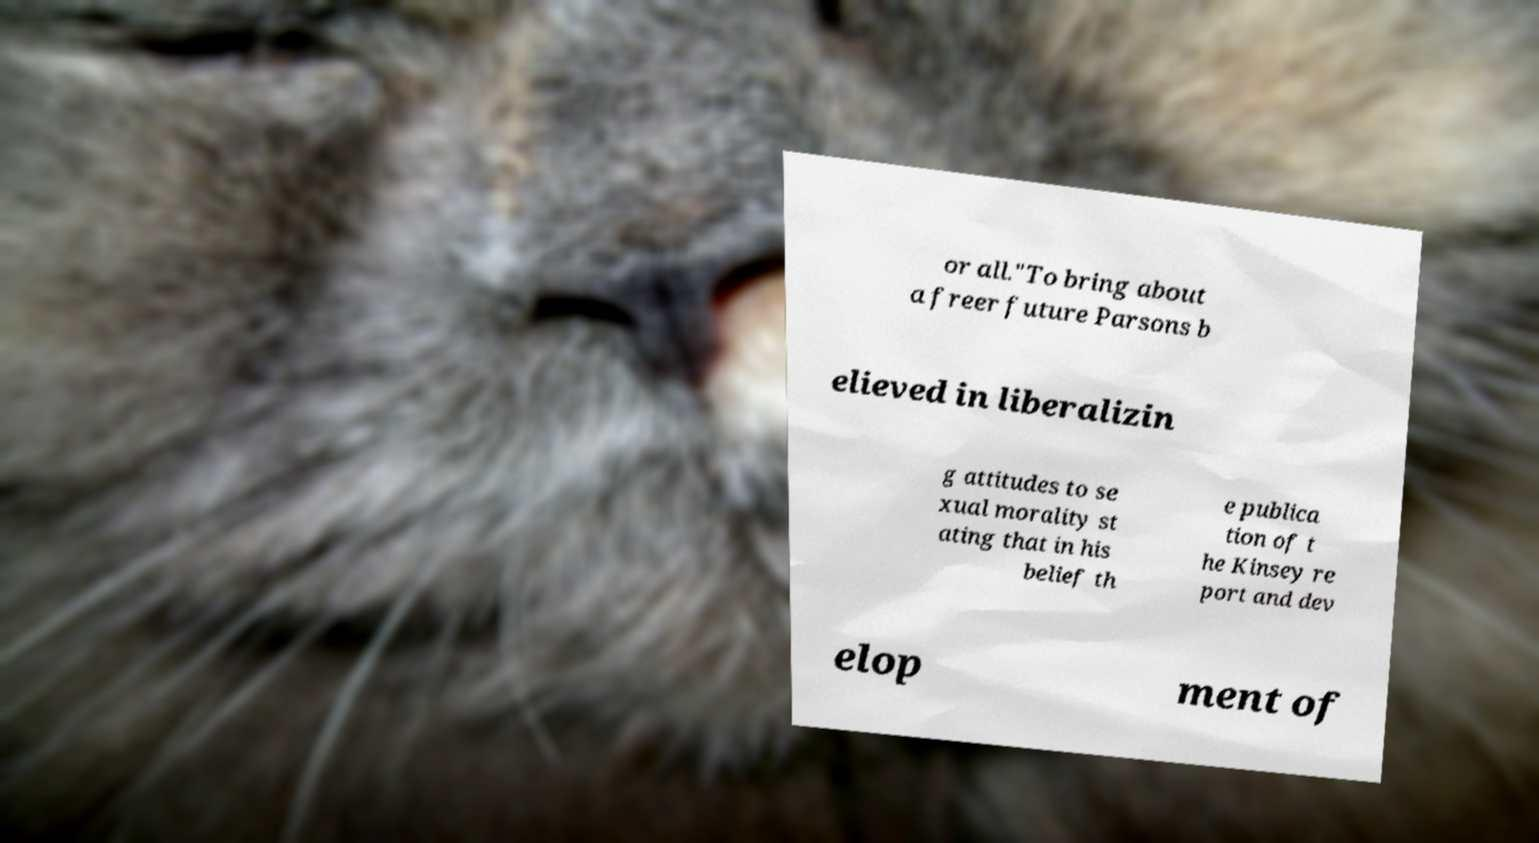Could you assist in decoding the text presented in this image and type it out clearly? or all."To bring about a freer future Parsons b elieved in liberalizin g attitudes to se xual morality st ating that in his belief th e publica tion of t he Kinsey re port and dev elop ment of 